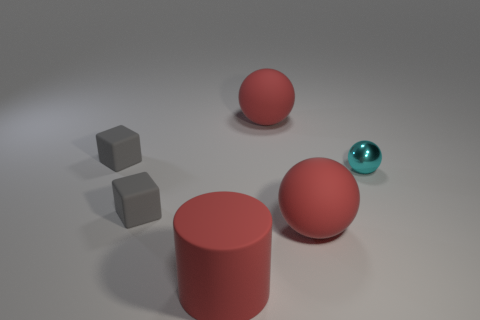Is there any other thing that has the same material as the small cyan ball?
Give a very brief answer. No. Are the tiny gray thing in front of the tiny ball and the cyan object made of the same material?
Your answer should be compact. No. What material is the large red cylinder?
Provide a succinct answer. Rubber. There is a large matte object that is behind the small thing on the right side of the red cylinder; what is its shape?
Offer a very short reply. Sphere. What shape is the tiny gray object behind the small ball?
Keep it short and to the point. Cube. What number of big matte cylinders have the same color as the tiny metallic ball?
Make the answer very short. 0. The cylinder is what color?
Keep it short and to the point. Red. There is a tiny thing that is on the right side of the matte cylinder; how many tiny metal things are behind it?
Give a very brief answer. 0. Does the cyan thing have the same size as the gray object behind the tiny cyan shiny ball?
Make the answer very short. Yes. Is the size of the cylinder the same as the shiny thing?
Your answer should be compact. No. 